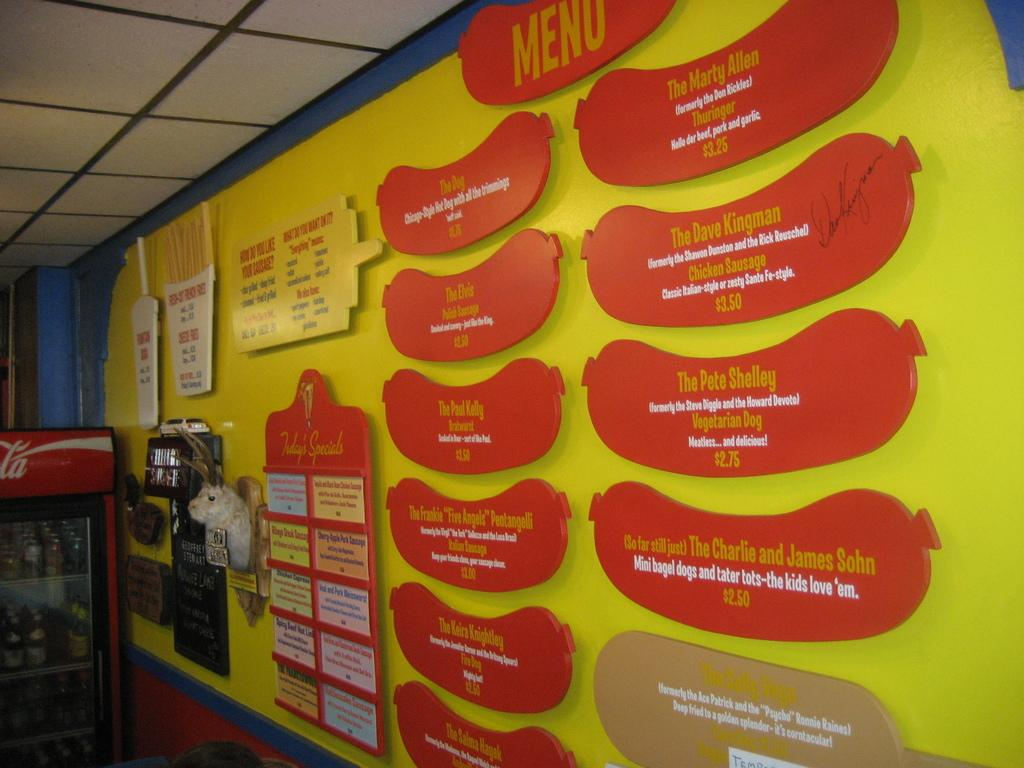<image>
Describe the image concisely. Yellow wall with hot dogs with the menu on them 